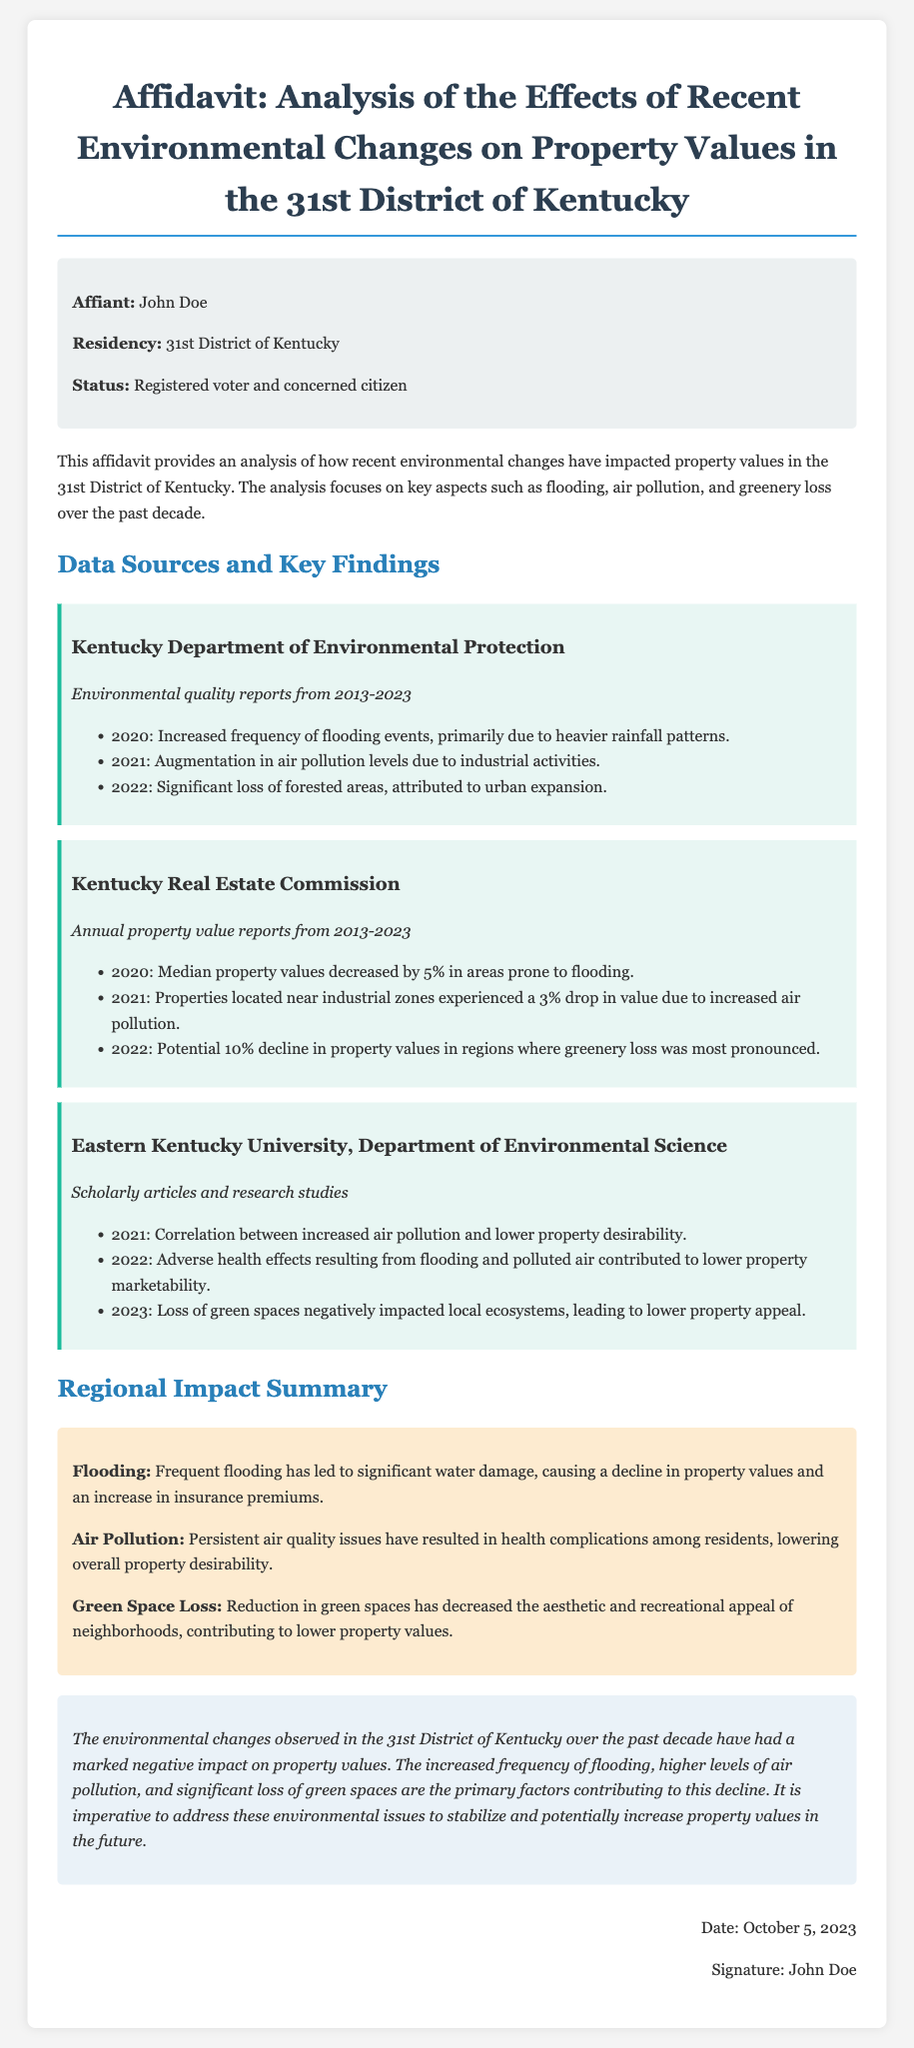what is the name of the affiant? The affiant is the person providing the affidavit, which is John Doe.
Answer: John Doe what is the primary environmental issue reported in 2020? The primary environmental issue reported in 2020 is the increased frequency of flooding events.
Answer: Flooding what percentage decline in median property values was noted in 2020? The document states that the median property values decreased by 5% in areas prone to flooding in 2020.
Answer: 5% what year did significant loss of forested areas occur? The document indicates that significant loss of forested areas occurred in 2022.
Answer: 2022 which institution provided scholarly articles for this affidavit? The institution that provided scholarly articles is Eastern Kentucky University, Department of Environmental Science.
Answer: Eastern Kentucky University what factor contributed to a potential 10% decline in property values in 2022? The potential 10% decline in property values was attributed to the loss of greenery.
Answer: Greenery loss what is the conclusion regarding the impact of environmental changes? The conclusion states that the environmental changes have had a marked negative impact on property values.
Answer: Marked negative impact what health problems arise from persistent air quality issues? Persistent air quality issues result in health complications among residents.
Answer: Health complications what date was the affidavit signed? The affidavit was signed on October 5, 2023.
Answer: October 5, 2023 